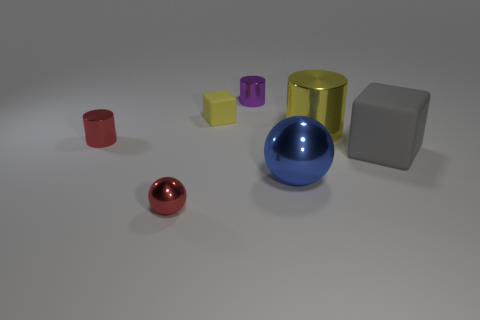What is the size of the red thing behind the tiny metallic sphere?
Your response must be concise. Small. There is a tiny matte block; is its color the same as the thing that is to the right of the yellow cylinder?
Give a very brief answer. No. Are there any cylinders of the same color as the tiny block?
Your answer should be compact. Yes. Are the big blue ball and the small red object that is behind the small red metallic ball made of the same material?
Give a very brief answer. Yes. How many tiny things are yellow objects or red shiny cylinders?
Make the answer very short. 2. There is a small cylinder that is the same color as the small sphere; what material is it?
Keep it short and to the point. Metal. Are there fewer small red cylinders than big brown things?
Ensure brevity in your answer.  No. Do the red object in front of the big block and the thing that is on the right side of the big yellow metal object have the same size?
Your answer should be very brief. No. How many red things are either small metal cylinders or large cylinders?
Your answer should be compact. 1. What size is the other thing that is the same color as the tiny rubber thing?
Your response must be concise. Large. 